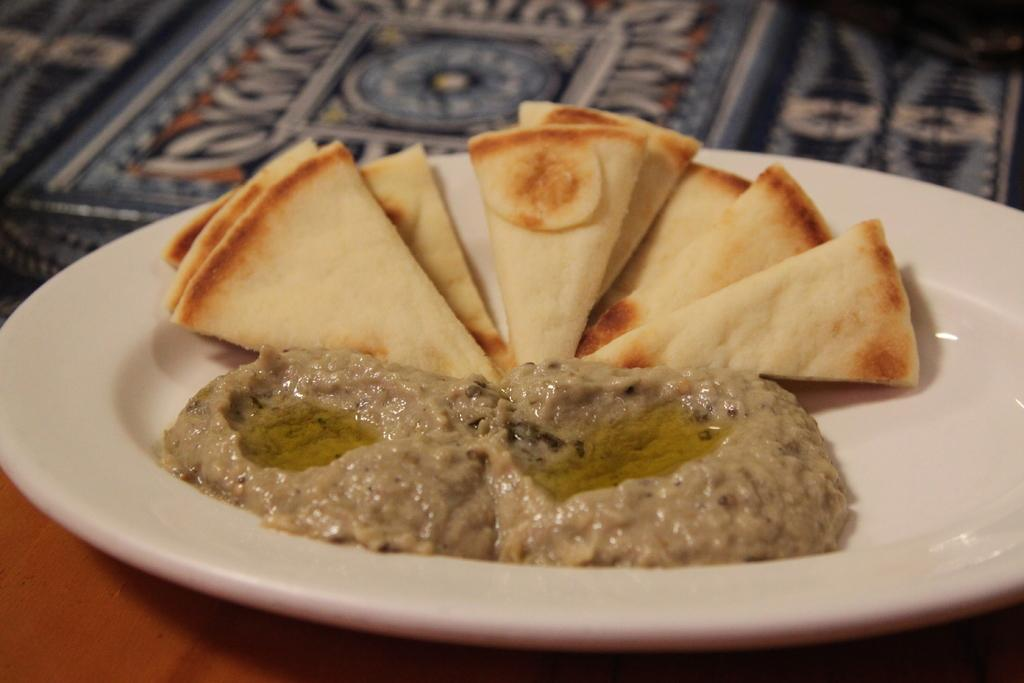What is present in the image that can be eaten? There is food in the image that can be eaten. How is the food arranged in the image? The food is placed on a plate in the image. What color is the plate that holds the food? The plate is white in color. Can you describe the flock of birds flying over the food in the image? There are no birds or flock present in the image; it only features food on a white plate. 